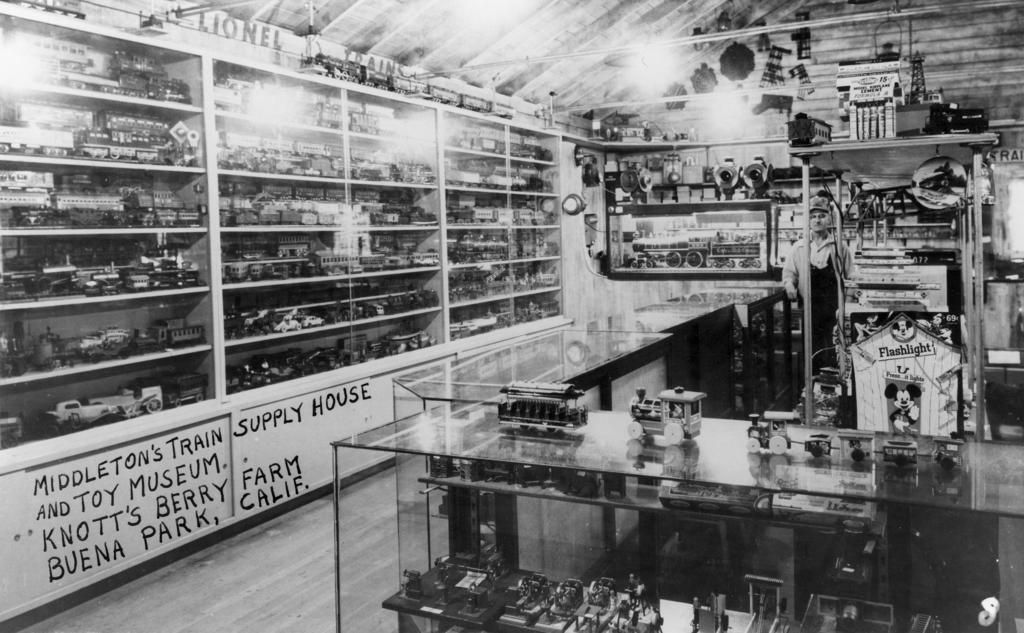<image>
Provide a brief description of the given image. A train store says Buena Park, Calif on the wall. 